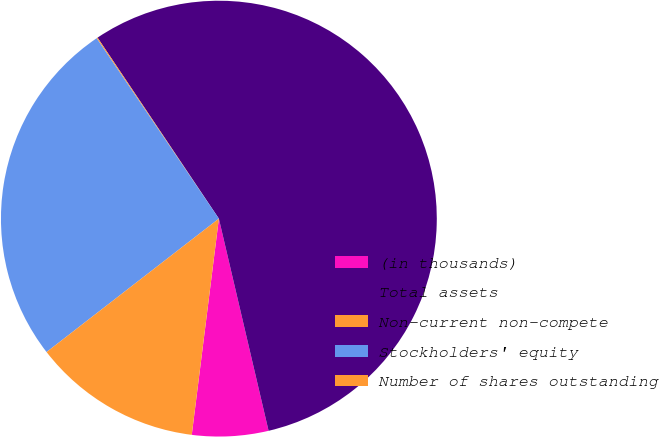Convert chart to OTSL. <chart><loc_0><loc_0><loc_500><loc_500><pie_chart><fcel>(in thousands)<fcel>Total assets<fcel>Non-current non-compete<fcel>Stockholders' equity<fcel>Number of shares outstanding<nl><fcel>5.65%<fcel>55.74%<fcel>0.08%<fcel>26.01%<fcel>12.53%<nl></chart> 